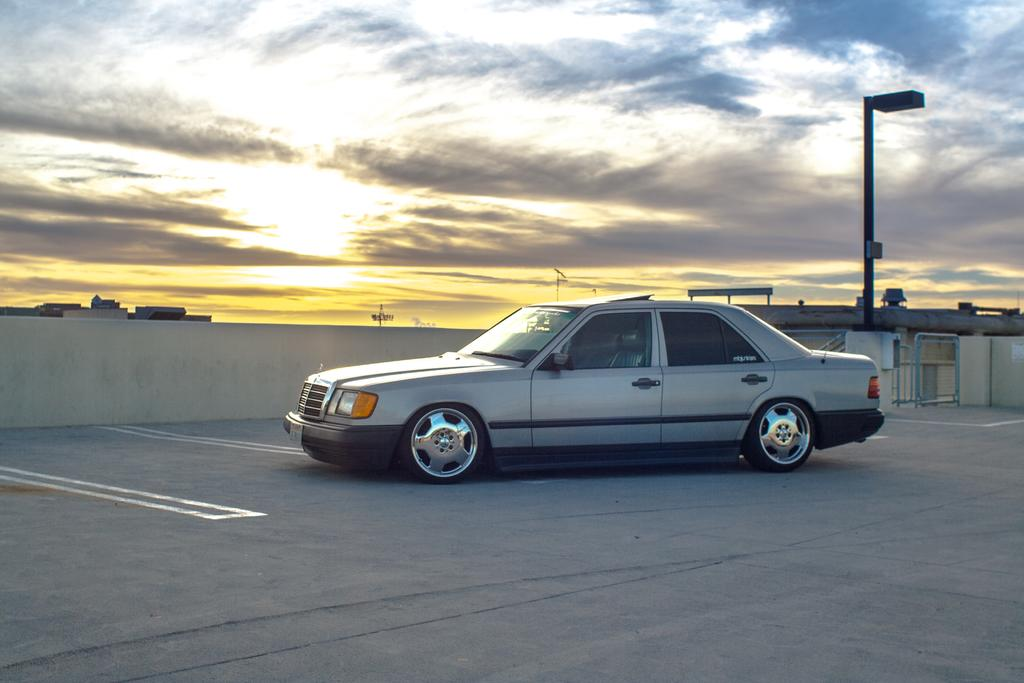What is the main subject of the image? The main subject of the image is a car. Where is the car located in the image? The car is on a pavement in the image. What can be seen behind the car in the image? There is a pole behind the car in the image. What type of dust can be seen on the jeans of the person sitting in the car? There is no person sitting in the car, nor are there any jeans visible in the image. 